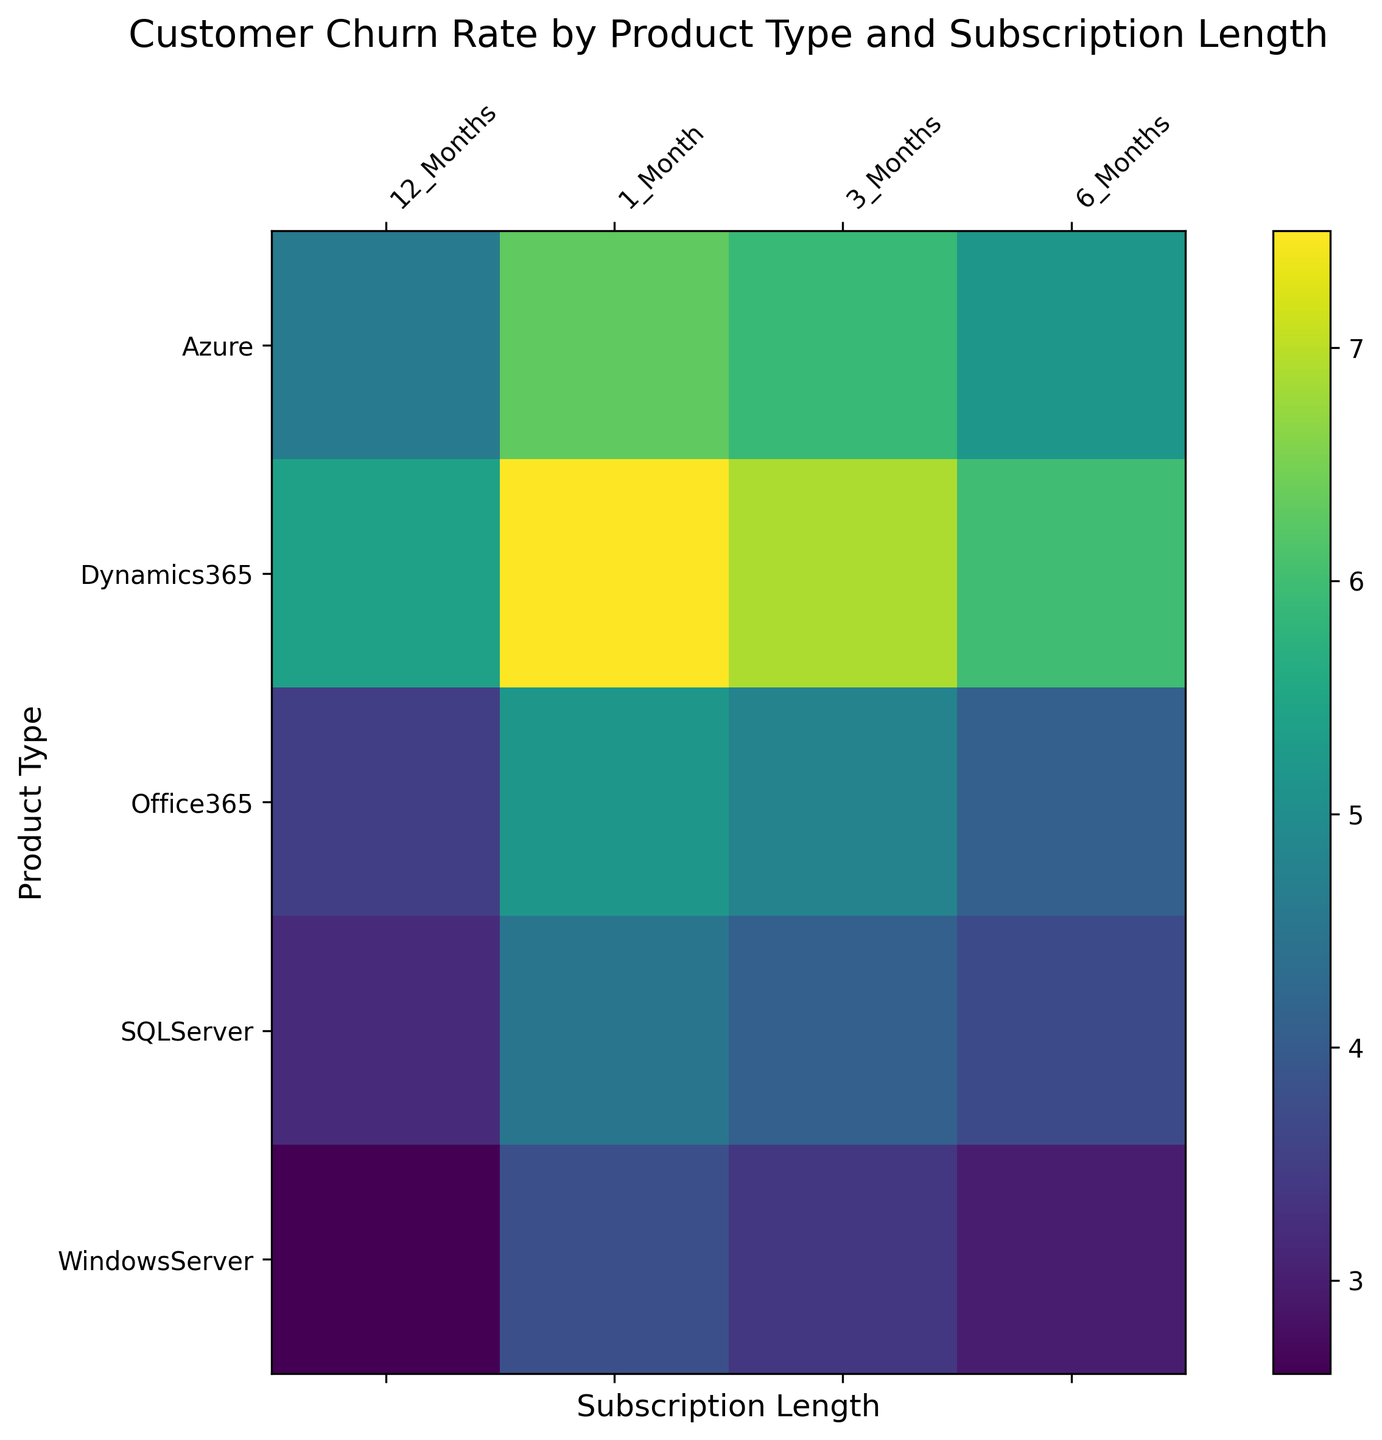What is the Churn Rate for Office365 with a 12-Month Subscription? Locate the intersection of the "Office365" row and the "12_Months" column. The Churn Rate at this intersection is 3.5.
Answer: 3.5 Which Product Type has the highest Churn Rate for a 1-Month Subscription? Look at the first column labeled "1_Month" for all Product Types. The highest value is 7.5, corresponding to "Dynamics365".
Answer: Dynamics365 How does the Churn Rate for Azure with a 6-Month Subscription compare to that of SQLServer with a 6-Month Subscription? Find the values at the intersections of "Azure" and "6_Months" as well as "SQLServer" and "6_Months". Azure’s value is 5.2 and SQLServer’s value is 3.7.
Answer: Azure has a higher Churn Rate compared to SQLServer What is the average Churn Rate for Office365 across all Subscription Lengths? Sum the values for Office365: 5.2, 4.8, 4.1, 3.5. The total is 17.6. Divide by the number of values, which is 4, to get the average: 17.6/4.
Answer: 4.4 What is the difference in Churn Rate between Dynamics365 with a 1-Month Subscription and WindowsServer with a 12-Month Subscription? Find the values: Dynamics365(1_Month) = 7.5 and WindowsServer(12_Months) = 2.6. Subtract the smaller value from the larger value: 7.5 - 2.6.
Answer: 4.9 Which Subscription Length shows the lowest Churn Rate for SQLServer? Compare the Churn Rates for SQLServer across all Subscription Lengths: 4.5, 4.1, 3.7, 3.2. The lowest value is 3.2.
Answer: 12_Months Are there any Product Types where the Churn Rate consistently decreases as the Subscription Length increases? Compare the values row-wise for each Product Type to see if there’s a consistent decrease in Churn Rate as you move from 1_Month to 12_Months. WindowsServer with rates: 3.8, 3.4, 3.0, 2.6 consistently decreases.
Answer: Yes, WindowsServer Which Product Type has the lowest Churn Rate overall, regardless of Subscription Length? Find the minimum Churn Rate value across the entire heatmap and identify the corresponding Product Type. The lowest value is 2.6 for "WindowsServer".
Answer: WindowsServer How much lower is the 12-Month Subscription Churn Rate of Office365 compared to its 1-Month Subscription Churn Rate? Find the values: Office365(12_Months) = 3.5 and Office365(1_Month) = 5.2. Subtract the 12-Month value from the 1-Month value: 5.2 - 3.5.
Answer: 1.7 What is the average Churn Rate for all Product Types with a 3-Month Subscription Length? Sum the values for 3-Month Subscription across all Product Types: 4.8, 5.9, 6.9, 3.4, 4.1. The total is 25.1. Divide by the number of values, which is 5, to get the average: 25.1/5.
Answer: 5.02 